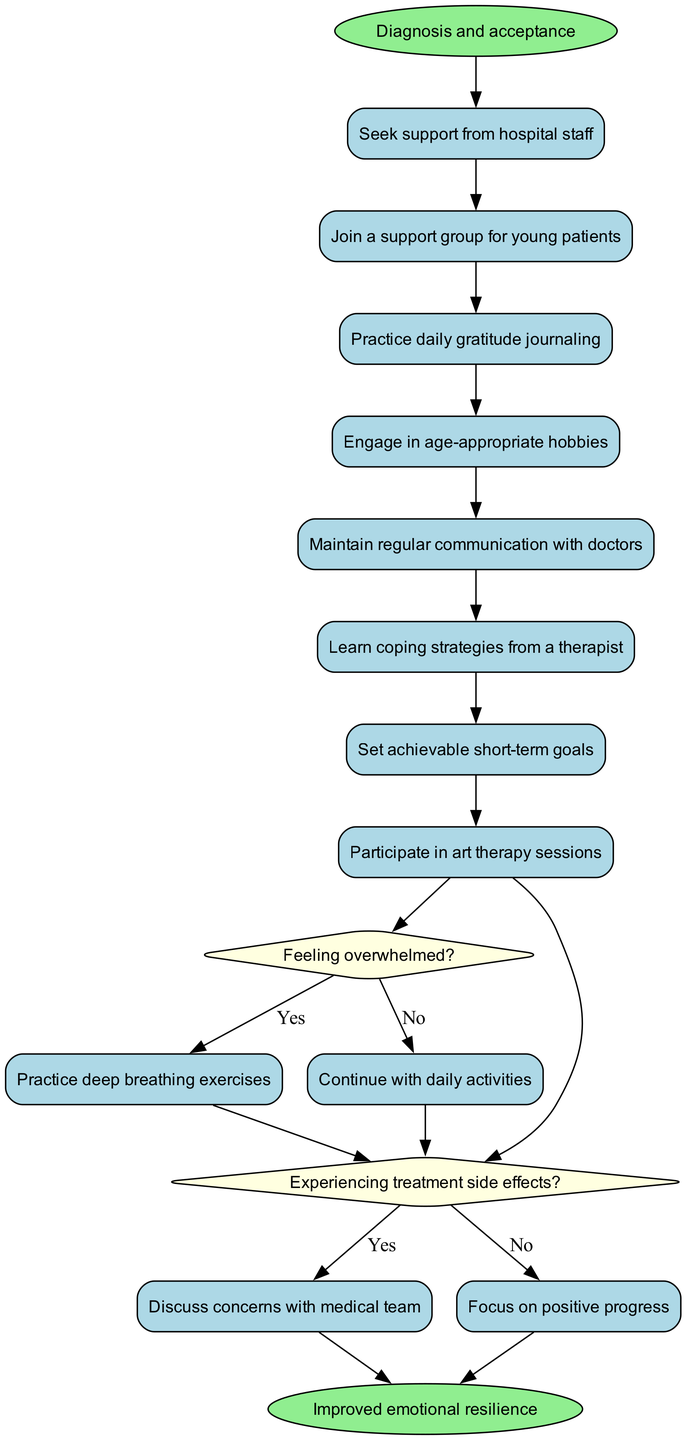What is the initial node labeled? The diagram starts with the initial node which is labeled "Diagnosis and acceptance."
Answer: Diagnosis and acceptance How many activities are included in this diagram? There are 8 activities listed in the diagram that pertain to maintaining mental health and emotional well-being.
Answer: 8 Which activity follows "Seek support from hospital staff"? Following "Seek support from hospital staff," the next activity is "Join a support group for young patients."
Answer: Join a support group for young patients What happens if you are feeling overwhelmed? If feeling overwhelmed, the next step is to "Practice deep breathing exercises."
Answer: Practice deep breathing exercises What should you do if you are experiencing treatment side effects? If experiencing treatment side effects, you should "Discuss concerns with medical team."
Answer: Discuss concerns with medical team How many decision points are there in the diagram? The diagram contains 2 decision points regarding feelings of being overwhelmed and treatment side effects.
Answer: 2 What is the final node called? The final node in the diagram is labeled "Improved emotional resilience."
Answer: Improved emotional resilience What should you focus on if you are not experiencing treatment side effects? If not experiencing treatment side effects, you should focus on "Positive progress."
Answer: Focus on positive progress What is the relationship between the activity "Practice daily gratitude journaling" and the final node? "Practice daily gratitude journaling" is one of the activities that leads through the decisions to the final node of improved emotional resilience.
Answer: Leads to improved emotional resilience 